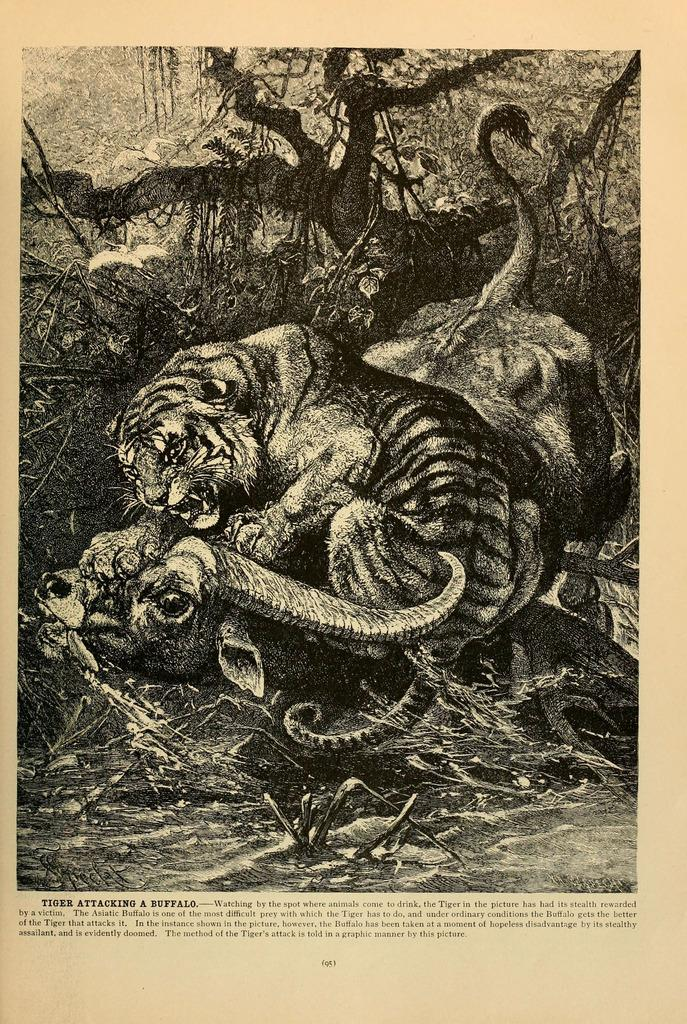What is the medium of the image? The image appears to be on paper. What is the main subject of the image? There is a picture of a tiger attacking a buffalo in the image. What type of vegetation can be seen in the image? There are trees visible in the image. What is written or depicted at the bottom of the image? There are letters at the bottom of the image. What time of day is it in the image? The image does not provide information about the time of day, as it is a static representation of a scene. How does the dog feel about the tiger attacking the buffalo in the image? There is no dog present in the image, so it is not possible to determine how a dog might feel about the scene. 